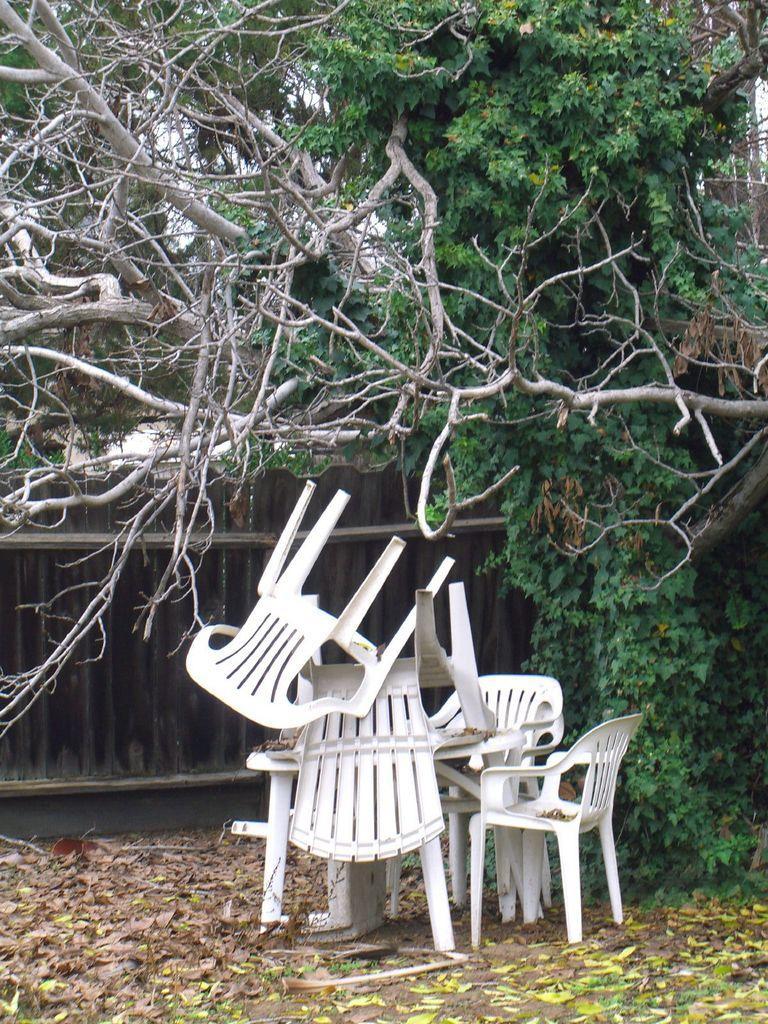Can you describe this image briefly? In the center of the image there are chairs. In the background of the image there is a gate. There are trees. At the bottom of the image there are leaves. 